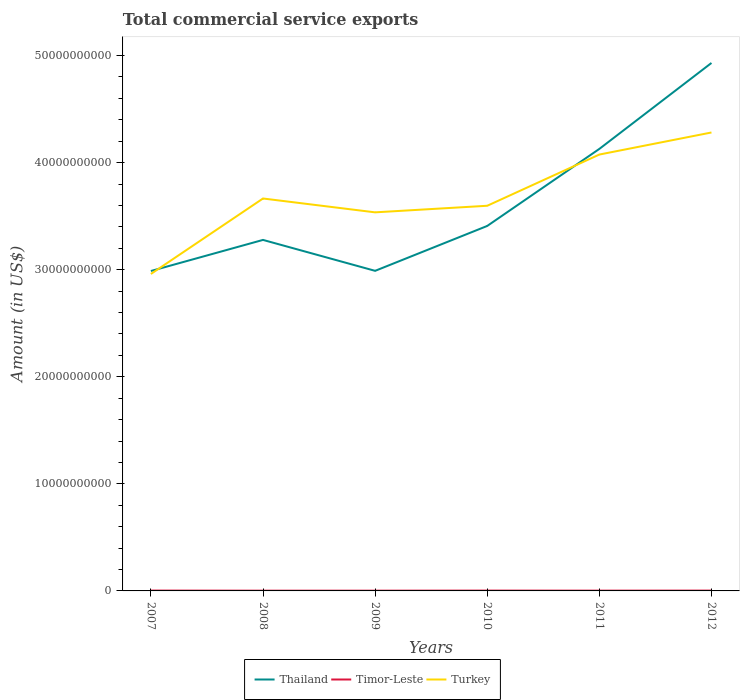How many different coloured lines are there?
Provide a succinct answer. 3. Does the line corresponding to Timor-Leste intersect with the line corresponding to Turkey?
Offer a terse response. No. Across all years, what is the maximum total commercial service exports in Thailand?
Make the answer very short. 2.99e+1. What is the total total commercial service exports in Thailand in the graph?
Make the answer very short. -7.19e+09. What is the difference between the highest and the second highest total commercial service exports in Thailand?
Offer a very short reply. 1.94e+1. How many lines are there?
Provide a short and direct response. 3. What is the difference between two consecutive major ticks on the Y-axis?
Keep it short and to the point. 1.00e+1. Does the graph contain grids?
Offer a very short reply. No. Where does the legend appear in the graph?
Keep it short and to the point. Bottom center. What is the title of the graph?
Make the answer very short. Total commercial service exports. What is the label or title of the X-axis?
Provide a succinct answer. Years. What is the label or title of the Y-axis?
Your response must be concise. Amount (in US$). What is the Amount (in US$) in Thailand in 2007?
Keep it short and to the point. 2.99e+1. What is the Amount (in US$) of Timor-Leste in 2007?
Offer a very short reply. 3.16e+07. What is the Amount (in US$) of Turkey in 2007?
Provide a succinct answer. 2.96e+1. What is the Amount (in US$) in Thailand in 2008?
Offer a very short reply. 3.28e+1. What is the Amount (in US$) of Timor-Leste in 2008?
Your response must be concise. 2.27e+07. What is the Amount (in US$) of Turkey in 2008?
Make the answer very short. 3.66e+1. What is the Amount (in US$) of Thailand in 2009?
Your answer should be compact. 2.99e+1. What is the Amount (in US$) in Timor-Leste in 2009?
Your answer should be very brief. 2.38e+07. What is the Amount (in US$) in Turkey in 2009?
Your response must be concise. 3.54e+1. What is the Amount (in US$) in Thailand in 2010?
Provide a succinct answer. 3.41e+1. What is the Amount (in US$) in Timor-Leste in 2010?
Offer a very short reply. 3.06e+07. What is the Amount (in US$) in Turkey in 2010?
Offer a terse response. 3.60e+1. What is the Amount (in US$) of Thailand in 2011?
Your answer should be very brief. 4.13e+1. What is the Amount (in US$) of Timor-Leste in 2011?
Your answer should be compact. 2.55e+07. What is the Amount (in US$) of Turkey in 2011?
Give a very brief answer. 4.08e+1. What is the Amount (in US$) in Thailand in 2012?
Offer a very short reply. 4.93e+1. What is the Amount (in US$) of Timor-Leste in 2012?
Ensure brevity in your answer.  3.02e+07. What is the Amount (in US$) in Turkey in 2012?
Offer a very short reply. 4.28e+1. Across all years, what is the maximum Amount (in US$) in Thailand?
Ensure brevity in your answer.  4.93e+1. Across all years, what is the maximum Amount (in US$) of Timor-Leste?
Your answer should be very brief. 3.16e+07. Across all years, what is the maximum Amount (in US$) in Turkey?
Provide a succinct answer. 4.28e+1. Across all years, what is the minimum Amount (in US$) in Thailand?
Provide a short and direct response. 2.99e+1. Across all years, what is the minimum Amount (in US$) in Timor-Leste?
Offer a very short reply. 2.27e+07. Across all years, what is the minimum Amount (in US$) in Turkey?
Keep it short and to the point. 2.96e+1. What is the total Amount (in US$) of Thailand in the graph?
Offer a terse response. 2.17e+11. What is the total Amount (in US$) in Timor-Leste in the graph?
Make the answer very short. 1.64e+08. What is the total Amount (in US$) of Turkey in the graph?
Offer a very short reply. 2.21e+11. What is the difference between the Amount (in US$) in Thailand in 2007 and that in 2008?
Provide a short and direct response. -2.90e+09. What is the difference between the Amount (in US$) of Timor-Leste in 2007 and that in 2008?
Provide a succinct answer. 8.88e+06. What is the difference between the Amount (in US$) in Turkey in 2007 and that in 2008?
Provide a short and direct response. -7.05e+09. What is the difference between the Amount (in US$) in Thailand in 2007 and that in 2009?
Offer a terse response. -1.67e+07. What is the difference between the Amount (in US$) of Timor-Leste in 2007 and that in 2009?
Ensure brevity in your answer.  7.71e+06. What is the difference between the Amount (in US$) in Turkey in 2007 and that in 2009?
Make the answer very short. -5.75e+09. What is the difference between the Amount (in US$) of Thailand in 2007 and that in 2010?
Ensure brevity in your answer.  -4.21e+09. What is the difference between the Amount (in US$) in Timor-Leste in 2007 and that in 2010?
Give a very brief answer. 9.52e+05. What is the difference between the Amount (in US$) in Turkey in 2007 and that in 2010?
Keep it short and to the point. -6.37e+09. What is the difference between the Amount (in US$) in Thailand in 2007 and that in 2011?
Your response must be concise. -1.14e+1. What is the difference between the Amount (in US$) of Timor-Leste in 2007 and that in 2011?
Offer a terse response. 6.04e+06. What is the difference between the Amount (in US$) in Turkey in 2007 and that in 2011?
Make the answer very short. -1.12e+1. What is the difference between the Amount (in US$) of Thailand in 2007 and that in 2012?
Keep it short and to the point. -1.94e+1. What is the difference between the Amount (in US$) of Timor-Leste in 2007 and that in 2012?
Your answer should be compact. 1.31e+06. What is the difference between the Amount (in US$) in Turkey in 2007 and that in 2012?
Provide a short and direct response. -1.32e+1. What is the difference between the Amount (in US$) in Thailand in 2008 and that in 2009?
Your answer should be very brief. 2.89e+09. What is the difference between the Amount (in US$) of Timor-Leste in 2008 and that in 2009?
Ensure brevity in your answer.  -1.17e+06. What is the difference between the Amount (in US$) of Turkey in 2008 and that in 2009?
Your answer should be very brief. 1.29e+09. What is the difference between the Amount (in US$) in Thailand in 2008 and that in 2010?
Make the answer very short. -1.30e+09. What is the difference between the Amount (in US$) in Timor-Leste in 2008 and that in 2010?
Your answer should be compact. -7.93e+06. What is the difference between the Amount (in US$) in Turkey in 2008 and that in 2010?
Offer a very short reply. 6.79e+08. What is the difference between the Amount (in US$) in Thailand in 2008 and that in 2011?
Provide a succinct answer. -8.50e+09. What is the difference between the Amount (in US$) of Timor-Leste in 2008 and that in 2011?
Ensure brevity in your answer.  -2.85e+06. What is the difference between the Amount (in US$) of Turkey in 2008 and that in 2011?
Provide a short and direct response. -4.10e+09. What is the difference between the Amount (in US$) of Thailand in 2008 and that in 2012?
Your response must be concise. -1.65e+1. What is the difference between the Amount (in US$) in Timor-Leste in 2008 and that in 2012?
Your response must be concise. -7.57e+06. What is the difference between the Amount (in US$) in Turkey in 2008 and that in 2012?
Keep it short and to the point. -6.16e+09. What is the difference between the Amount (in US$) of Thailand in 2009 and that in 2010?
Your answer should be compact. -4.19e+09. What is the difference between the Amount (in US$) in Timor-Leste in 2009 and that in 2010?
Offer a very short reply. -6.76e+06. What is the difference between the Amount (in US$) of Turkey in 2009 and that in 2010?
Provide a succinct answer. -6.15e+08. What is the difference between the Amount (in US$) in Thailand in 2009 and that in 2011?
Give a very brief answer. -1.14e+1. What is the difference between the Amount (in US$) in Timor-Leste in 2009 and that in 2011?
Provide a short and direct response. -1.67e+06. What is the difference between the Amount (in US$) of Turkey in 2009 and that in 2011?
Offer a very short reply. -5.40e+09. What is the difference between the Amount (in US$) in Thailand in 2009 and that in 2012?
Your response must be concise. -1.94e+1. What is the difference between the Amount (in US$) in Timor-Leste in 2009 and that in 2012?
Your answer should be very brief. -6.40e+06. What is the difference between the Amount (in US$) of Turkey in 2009 and that in 2012?
Make the answer very short. -7.46e+09. What is the difference between the Amount (in US$) in Thailand in 2010 and that in 2011?
Keep it short and to the point. -7.19e+09. What is the difference between the Amount (in US$) of Timor-Leste in 2010 and that in 2011?
Provide a short and direct response. 5.08e+06. What is the difference between the Amount (in US$) of Turkey in 2010 and that in 2011?
Provide a succinct answer. -4.78e+09. What is the difference between the Amount (in US$) in Thailand in 2010 and that in 2012?
Ensure brevity in your answer.  -1.52e+1. What is the difference between the Amount (in US$) in Timor-Leste in 2010 and that in 2012?
Offer a terse response. 3.61e+05. What is the difference between the Amount (in US$) in Turkey in 2010 and that in 2012?
Keep it short and to the point. -6.84e+09. What is the difference between the Amount (in US$) of Thailand in 2011 and that in 2012?
Keep it short and to the point. -8.03e+09. What is the difference between the Amount (in US$) in Timor-Leste in 2011 and that in 2012?
Provide a succinct answer. -4.72e+06. What is the difference between the Amount (in US$) in Turkey in 2011 and that in 2012?
Make the answer very short. -2.06e+09. What is the difference between the Amount (in US$) of Thailand in 2007 and the Amount (in US$) of Timor-Leste in 2008?
Your response must be concise. 2.99e+1. What is the difference between the Amount (in US$) in Thailand in 2007 and the Amount (in US$) in Turkey in 2008?
Your answer should be compact. -6.77e+09. What is the difference between the Amount (in US$) of Timor-Leste in 2007 and the Amount (in US$) of Turkey in 2008?
Provide a succinct answer. -3.66e+1. What is the difference between the Amount (in US$) in Thailand in 2007 and the Amount (in US$) in Timor-Leste in 2009?
Offer a very short reply. 2.99e+1. What is the difference between the Amount (in US$) in Thailand in 2007 and the Amount (in US$) in Turkey in 2009?
Your answer should be very brief. -5.48e+09. What is the difference between the Amount (in US$) in Timor-Leste in 2007 and the Amount (in US$) in Turkey in 2009?
Provide a short and direct response. -3.53e+1. What is the difference between the Amount (in US$) of Thailand in 2007 and the Amount (in US$) of Timor-Leste in 2010?
Make the answer very short. 2.98e+1. What is the difference between the Amount (in US$) in Thailand in 2007 and the Amount (in US$) in Turkey in 2010?
Offer a very short reply. -6.09e+09. What is the difference between the Amount (in US$) in Timor-Leste in 2007 and the Amount (in US$) in Turkey in 2010?
Your answer should be compact. -3.59e+1. What is the difference between the Amount (in US$) in Thailand in 2007 and the Amount (in US$) in Timor-Leste in 2011?
Ensure brevity in your answer.  2.99e+1. What is the difference between the Amount (in US$) in Thailand in 2007 and the Amount (in US$) in Turkey in 2011?
Your response must be concise. -1.09e+1. What is the difference between the Amount (in US$) of Timor-Leste in 2007 and the Amount (in US$) of Turkey in 2011?
Provide a succinct answer. -4.07e+1. What is the difference between the Amount (in US$) in Thailand in 2007 and the Amount (in US$) in Timor-Leste in 2012?
Your answer should be compact. 2.98e+1. What is the difference between the Amount (in US$) in Thailand in 2007 and the Amount (in US$) in Turkey in 2012?
Make the answer very short. -1.29e+1. What is the difference between the Amount (in US$) of Timor-Leste in 2007 and the Amount (in US$) of Turkey in 2012?
Ensure brevity in your answer.  -4.28e+1. What is the difference between the Amount (in US$) of Thailand in 2008 and the Amount (in US$) of Timor-Leste in 2009?
Make the answer very short. 3.28e+1. What is the difference between the Amount (in US$) in Thailand in 2008 and the Amount (in US$) in Turkey in 2009?
Offer a very short reply. -2.57e+09. What is the difference between the Amount (in US$) of Timor-Leste in 2008 and the Amount (in US$) of Turkey in 2009?
Provide a short and direct response. -3.53e+1. What is the difference between the Amount (in US$) in Thailand in 2008 and the Amount (in US$) in Timor-Leste in 2010?
Offer a terse response. 3.28e+1. What is the difference between the Amount (in US$) of Thailand in 2008 and the Amount (in US$) of Turkey in 2010?
Give a very brief answer. -3.19e+09. What is the difference between the Amount (in US$) of Timor-Leste in 2008 and the Amount (in US$) of Turkey in 2010?
Offer a very short reply. -3.59e+1. What is the difference between the Amount (in US$) in Thailand in 2008 and the Amount (in US$) in Timor-Leste in 2011?
Your answer should be very brief. 3.28e+1. What is the difference between the Amount (in US$) in Thailand in 2008 and the Amount (in US$) in Turkey in 2011?
Your answer should be compact. -7.97e+09. What is the difference between the Amount (in US$) of Timor-Leste in 2008 and the Amount (in US$) of Turkey in 2011?
Ensure brevity in your answer.  -4.07e+1. What is the difference between the Amount (in US$) of Thailand in 2008 and the Amount (in US$) of Timor-Leste in 2012?
Your answer should be very brief. 3.28e+1. What is the difference between the Amount (in US$) in Thailand in 2008 and the Amount (in US$) in Turkey in 2012?
Provide a short and direct response. -1.00e+1. What is the difference between the Amount (in US$) in Timor-Leste in 2008 and the Amount (in US$) in Turkey in 2012?
Give a very brief answer. -4.28e+1. What is the difference between the Amount (in US$) in Thailand in 2009 and the Amount (in US$) in Timor-Leste in 2010?
Ensure brevity in your answer.  2.99e+1. What is the difference between the Amount (in US$) of Thailand in 2009 and the Amount (in US$) of Turkey in 2010?
Provide a succinct answer. -6.08e+09. What is the difference between the Amount (in US$) of Timor-Leste in 2009 and the Amount (in US$) of Turkey in 2010?
Offer a terse response. -3.59e+1. What is the difference between the Amount (in US$) of Thailand in 2009 and the Amount (in US$) of Timor-Leste in 2011?
Provide a short and direct response. 2.99e+1. What is the difference between the Amount (in US$) in Thailand in 2009 and the Amount (in US$) in Turkey in 2011?
Ensure brevity in your answer.  -1.09e+1. What is the difference between the Amount (in US$) in Timor-Leste in 2009 and the Amount (in US$) in Turkey in 2011?
Provide a short and direct response. -4.07e+1. What is the difference between the Amount (in US$) in Thailand in 2009 and the Amount (in US$) in Timor-Leste in 2012?
Offer a terse response. 2.99e+1. What is the difference between the Amount (in US$) of Thailand in 2009 and the Amount (in US$) of Turkey in 2012?
Offer a very short reply. -1.29e+1. What is the difference between the Amount (in US$) of Timor-Leste in 2009 and the Amount (in US$) of Turkey in 2012?
Your answer should be very brief. -4.28e+1. What is the difference between the Amount (in US$) of Thailand in 2010 and the Amount (in US$) of Timor-Leste in 2011?
Offer a terse response. 3.41e+1. What is the difference between the Amount (in US$) in Thailand in 2010 and the Amount (in US$) in Turkey in 2011?
Your answer should be compact. -6.67e+09. What is the difference between the Amount (in US$) in Timor-Leste in 2010 and the Amount (in US$) in Turkey in 2011?
Your answer should be very brief. -4.07e+1. What is the difference between the Amount (in US$) of Thailand in 2010 and the Amount (in US$) of Timor-Leste in 2012?
Ensure brevity in your answer.  3.41e+1. What is the difference between the Amount (in US$) in Thailand in 2010 and the Amount (in US$) in Turkey in 2012?
Your answer should be very brief. -8.73e+09. What is the difference between the Amount (in US$) in Timor-Leste in 2010 and the Amount (in US$) in Turkey in 2012?
Make the answer very short. -4.28e+1. What is the difference between the Amount (in US$) in Thailand in 2011 and the Amount (in US$) in Timor-Leste in 2012?
Make the answer very short. 4.13e+1. What is the difference between the Amount (in US$) of Thailand in 2011 and the Amount (in US$) of Turkey in 2012?
Make the answer very short. -1.53e+09. What is the difference between the Amount (in US$) of Timor-Leste in 2011 and the Amount (in US$) of Turkey in 2012?
Offer a very short reply. -4.28e+1. What is the average Amount (in US$) of Thailand per year?
Keep it short and to the point. 3.62e+1. What is the average Amount (in US$) of Timor-Leste per year?
Offer a terse response. 2.74e+07. What is the average Amount (in US$) in Turkey per year?
Your answer should be very brief. 3.69e+1. In the year 2007, what is the difference between the Amount (in US$) in Thailand and Amount (in US$) in Timor-Leste?
Keep it short and to the point. 2.98e+1. In the year 2007, what is the difference between the Amount (in US$) in Thailand and Amount (in US$) in Turkey?
Your answer should be compact. 2.75e+08. In the year 2007, what is the difference between the Amount (in US$) in Timor-Leste and Amount (in US$) in Turkey?
Your response must be concise. -2.96e+1. In the year 2008, what is the difference between the Amount (in US$) of Thailand and Amount (in US$) of Timor-Leste?
Ensure brevity in your answer.  3.28e+1. In the year 2008, what is the difference between the Amount (in US$) in Thailand and Amount (in US$) in Turkey?
Give a very brief answer. -3.87e+09. In the year 2008, what is the difference between the Amount (in US$) of Timor-Leste and Amount (in US$) of Turkey?
Offer a very short reply. -3.66e+1. In the year 2009, what is the difference between the Amount (in US$) of Thailand and Amount (in US$) of Timor-Leste?
Give a very brief answer. 2.99e+1. In the year 2009, what is the difference between the Amount (in US$) in Thailand and Amount (in US$) in Turkey?
Offer a very short reply. -5.46e+09. In the year 2009, what is the difference between the Amount (in US$) in Timor-Leste and Amount (in US$) in Turkey?
Offer a very short reply. -3.53e+1. In the year 2010, what is the difference between the Amount (in US$) of Thailand and Amount (in US$) of Timor-Leste?
Your answer should be very brief. 3.41e+1. In the year 2010, what is the difference between the Amount (in US$) in Thailand and Amount (in US$) in Turkey?
Your response must be concise. -1.88e+09. In the year 2010, what is the difference between the Amount (in US$) in Timor-Leste and Amount (in US$) in Turkey?
Your answer should be very brief. -3.59e+1. In the year 2011, what is the difference between the Amount (in US$) of Thailand and Amount (in US$) of Timor-Leste?
Provide a short and direct response. 4.13e+1. In the year 2011, what is the difference between the Amount (in US$) of Thailand and Amount (in US$) of Turkey?
Your answer should be compact. 5.27e+08. In the year 2011, what is the difference between the Amount (in US$) in Timor-Leste and Amount (in US$) in Turkey?
Provide a short and direct response. -4.07e+1. In the year 2012, what is the difference between the Amount (in US$) in Thailand and Amount (in US$) in Timor-Leste?
Provide a succinct answer. 4.93e+1. In the year 2012, what is the difference between the Amount (in US$) in Thailand and Amount (in US$) in Turkey?
Your response must be concise. 6.49e+09. In the year 2012, what is the difference between the Amount (in US$) in Timor-Leste and Amount (in US$) in Turkey?
Give a very brief answer. -4.28e+1. What is the ratio of the Amount (in US$) in Thailand in 2007 to that in 2008?
Your answer should be very brief. 0.91. What is the ratio of the Amount (in US$) in Timor-Leste in 2007 to that in 2008?
Ensure brevity in your answer.  1.39. What is the ratio of the Amount (in US$) in Turkey in 2007 to that in 2008?
Provide a short and direct response. 0.81. What is the ratio of the Amount (in US$) in Timor-Leste in 2007 to that in 2009?
Provide a succinct answer. 1.32. What is the ratio of the Amount (in US$) in Turkey in 2007 to that in 2009?
Provide a short and direct response. 0.84. What is the ratio of the Amount (in US$) of Thailand in 2007 to that in 2010?
Offer a very short reply. 0.88. What is the ratio of the Amount (in US$) in Timor-Leste in 2007 to that in 2010?
Provide a short and direct response. 1.03. What is the ratio of the Amount (in US$) of Turkey in 2007 to that in 2010?
Provide a succinct answer. 0.82. What is the ratio of the Amount (in US$) in Thailand in 2007 to that in 2011?
Provide a short and direct response. 0.72. What is the ratio of the Amount (in US$) in Timor-Leste in 2007 to that in 2011?
Provide a succinct answer. 1.24. What is the ratio of the Amount (in US$) of Turkey in 2007 to that in 2011?
Make the answer very short. 0.73. What is the ratio of the Amount (in US$) of Thailand in 2007 to that in 2012?
Your answer should be very brief. 0.61. What is the ratio of the Amount (in US$) in Timor-Leste in 2007 to that in 2012?
Offer a very short reply. 1.04. What is the ratio of the Amount (in US$) of Turkey in 2007 to that in 2012?
Provide a succinct answer. 0.69. What is the ratio of the Amount (in US$) of Thailand in 2008 to that in 2009?
Offer a terse response. 1.1. What is the ratio of the Amount (in US$) in Timor-Leste in 2008 to that in 2009?
Your answer should be compact. 0.95. What is the ratio of the Amount (in US$) in Turkey in 2008 to that in 2009?
Keep it short and to the point. 1.04. What is the ratio of the Amount (in US$) in Thailand in 2008 to that in 2010?
Your response must be concise. 0.96. What is the ratio of the Amount (in US$) of Timor-Leste in 2008 to that in 2010?
Provide a short and direct response. 0.74. What is the ratio of the Amount (in US$) in Turkey in 2008 to that in 2010?
Offer a terse response. 1.02. What is the ratio of the Amount (in US$) of Thailand in 2008 to that in 2011?
Ensure brevity in your answer.  0.79. What is the ratio of the Amount (in US$) in Timor-Leste in 2008 to that in 2011?
Offer a terse response. 0.89. What is the ratio of the Amount (in US$) in Turkey in 2008 to that in 2011?
Provide a short and direct response. 0.9. What is the ratio of the Amount (in US$) of Thailand in 2008 to that in 2012?
Your answer should be very brief. 0.66. What is the ratio of the Amount (in US$) of Timor-Leste in 2008 to that in 2012?
Offer a very short reply. 0.75. What is the ratio of the Amount (in US$) of Turkey in 2008 to that in 2012?
Your answer should be very brief. 0.86. What is the ratio of the Amount (in US$) in Thailand in 2009 to that in 2010?
Offer a very short reply. 0.88. What is the ratio of the Amount (in US$) of Timor-Leste in 2009 to that in 2010?
Provide a succinct answer. 0.78. What is the ratio of the Amount (in US$) in Turkey in 2009 to that in 2010?
Give a very brief answer. 0.98. What is the ratio of the Amount (in US$) of Thailand in 2009 to that in 2011?
Provide a short and direct response. 0.72. What is the ratio of the Amount (in US$) in Timor-Leste in 2009 to that in 2011?
Provide a succinct answer. 0.93. What is the ratio of the Amount (in US$) in Turkey in 2009 to that in 2011?
Provide a short and direct response. 0.87. What is the ratio of the Amount (in US$) in Thailand in 2009 to that in 2012?
Your answer should be very brief. 0.61. What is the ratio of the Amount (in US$) in Timor-Leste in 2009 to that in 2012?
Your response must be concise. 0.79. What is the ratio of the Amount (in US$) of Turkey in 2009 to that in 2012?
Provide a short and direct response. 0.83. What is the ratio of the Amount (in US$) of Thailand in 2010 to that in 2011?
Provide a short and direct response. 0.83. What is the ratio of the Amount (in US$) in Timor-Leste in 2010 to that in 2011?
Offer a terse response. 1.2. What is the ratio of the Amount (in US$) in Turkey in 2010 to that in 2011?
Your answer should be very brief. 0.88. What is the ratio of the Amount (in US$) of Thailand in 2010 to that in 2012?
Make the answer very short. 0.69. What is the ratio of the Amount (in US$) of Timor-Leste in 2010 to that in 2012?
Offer a very short reply. 1.01. What is the ratio of the Amount (in US$) of Turkey in 2010 to that in 2012?
Keep it short and to the point. 0.84. What is the ratio of the Amount (in US$) of Thailand in 2011 to that in 2012?
Offer a terse response. 0.84. What is the ratio of the Amount (in US$) in Timor-Leste in 2011 to that in 2012?
Your answer should be very brief. 0.84. What is the ratio of the Amount (in US$) of Turkey in 2011 to that in 2012?
Your answer should be compact. 0.95. What is the difference between the highest and the second highest Amount (in US$) of Thailand?
Offer a very short reply. 8.03e+09. What is the difference between the highest and the second highest Amount (in US$) of Timor-Leste?
Make the answer very short. 9.52e+05. What is the difference between the highest and the second highest Amount (in US$) in Turkey?
Your response must be concise. 2.06e+09. What is the difference between the highest and the lowest Amount (in US$) of Thailand?
Provide a short and direct response. 1.94e+1. What is the difference between the highest and the lowest Amount (in US$) in Timor-Leste?
Offer a terse response. 8.88e+06. What is the difference between the highest and the lowest Amount (in US$) of Turkey?
Offer a terse response. 1.32e+1. 